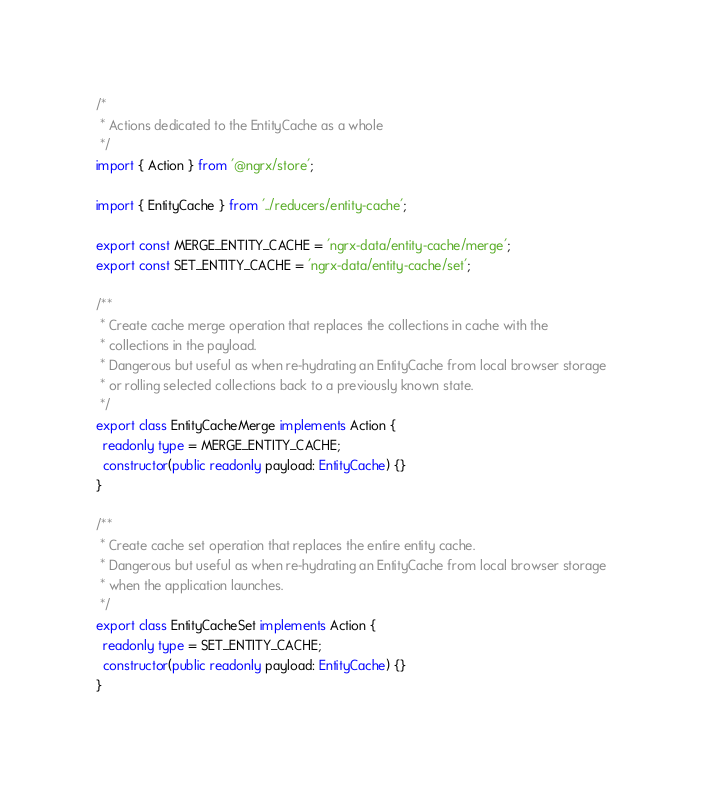<code> <loc_0><loc_0><loc_500><loc_500><_TypeScript_>/*
 * Actions dedicated to the EntityCache as a whole
 */
import { Action } from '@ngrx/store';

import { EntityCache } from '../reducers/entity-cache';

export const MERGE_ENTITY_CACHE = 'ngrx-data/entity-cache/merge';
export const SET_ENTITY_CACHE = 'ngrx-data/entity-cache/set';

/**
 * Create cache merge operation that replaces the collections in cache with the
 * collections in the payload.
 * Dangerous but useful as when re-hydrating an EntityCache from local browser storage
 * or rolling selected collections back to a previously known state.
 */
export class EntityCacheMerge implements Action {
  readonly type = MERGE_ENTITY_CACHE;
  constructor(public readonly payload: EntityCache) {}
}

/**
 * Create cache set operation that replaces the entire entity cache.
 * Dangerous but useful as when re-hydrating an EntityCache from local browser storage
 * when the application launches.
 */
export class EntityCacheSet implements Action {
  readonly type = SET_ENTITY_CACHE;
  constructor(public readonly payload: EntityCache) {}
}
</code> 